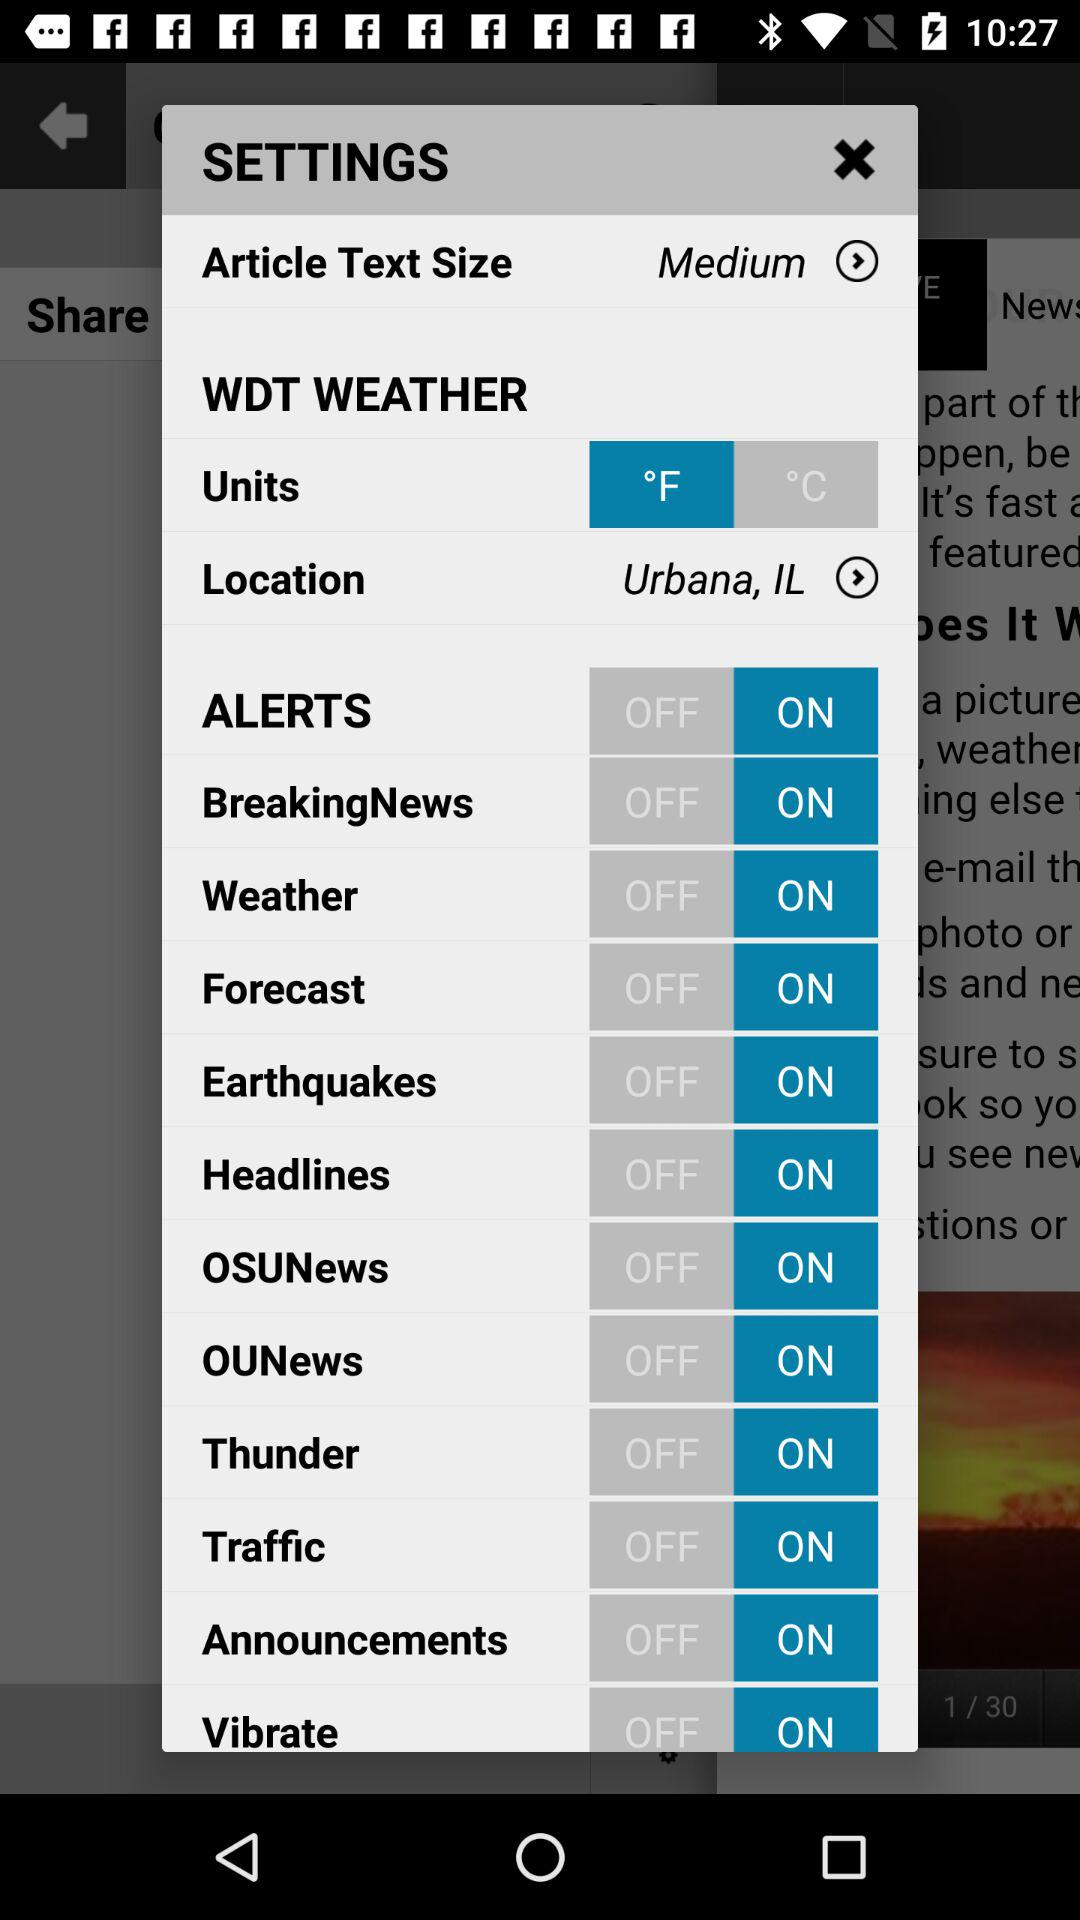What is the status of "BreakingNews"? The status is "on". 